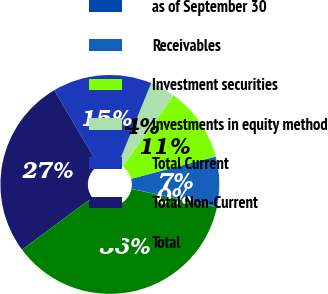Convert chart. <chart><loc_0><loc_0><loc_500><loc_500><pie_chart><fcel>as of September 30<fcel>Receivables<fcel>Investment securities<fcel>Investments in equity method<fcel>Total Current<fcel>Total Non-Current<fcel>Total<nl><fcel>0.08%<fcel>7.37%<fcel>11.01%<fcel>3.72%<fcel>14.65%<fcel>26.68%<fcel>36.49%<nl></chart> 